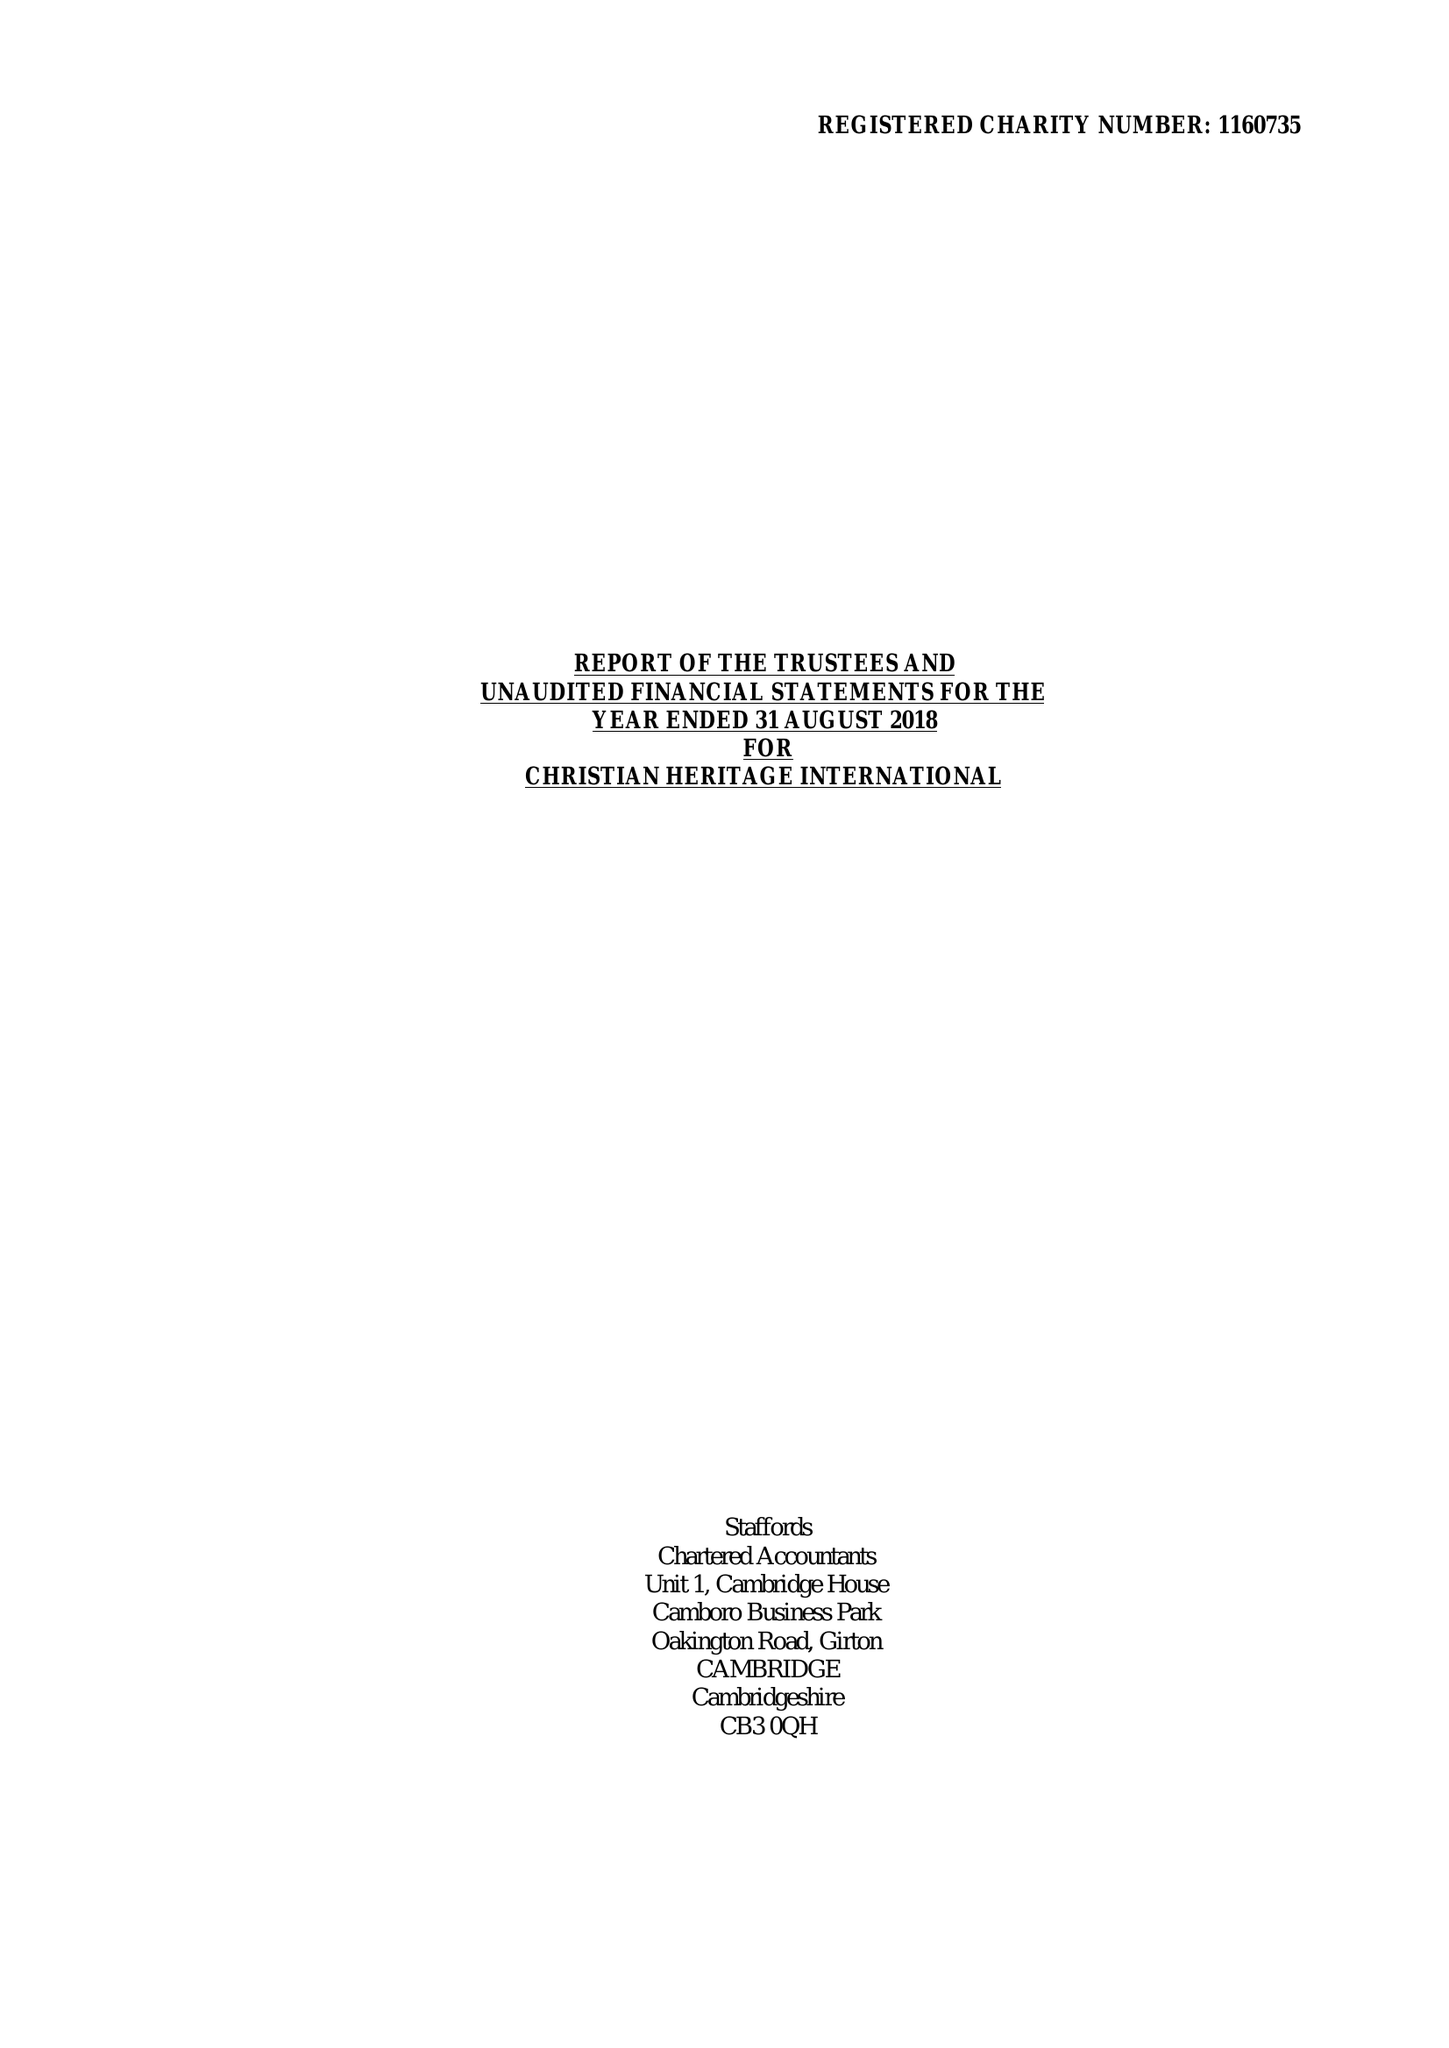What is the value for the income_annually_in_british_pounds?
Answer the question using a single word or phrase. None 